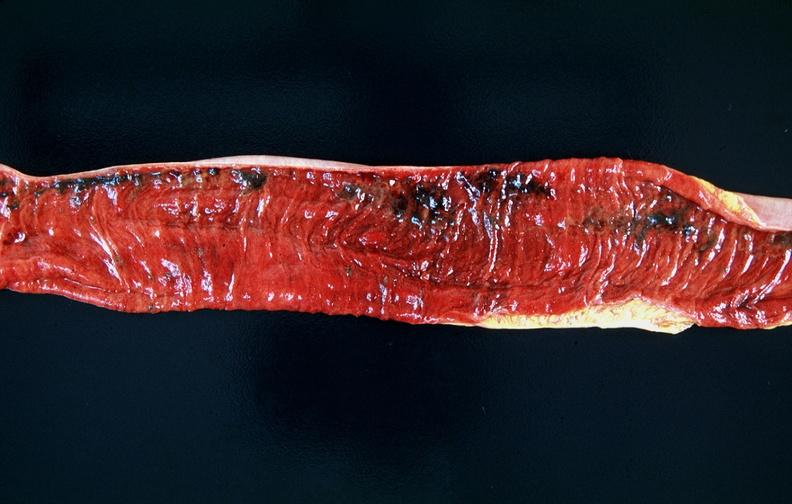what is present?
Answer the question using a single word or phrase. Gastrointestinal 